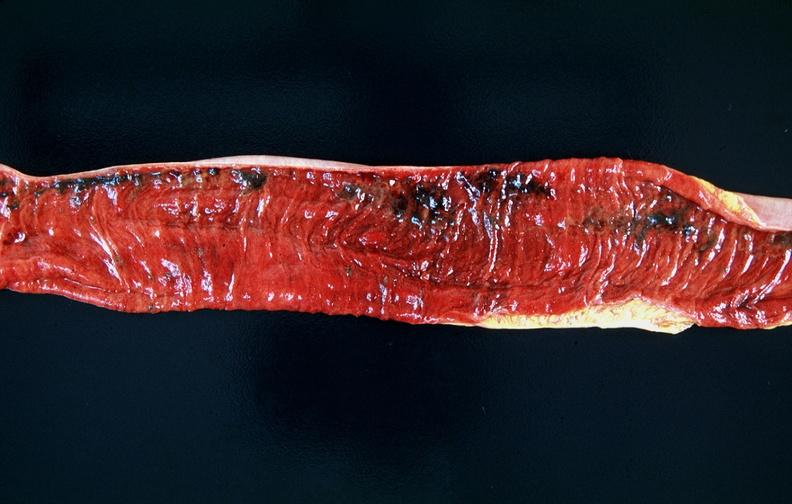what is present?
Answer the question using a single word or phrase. Gastrointestinal 